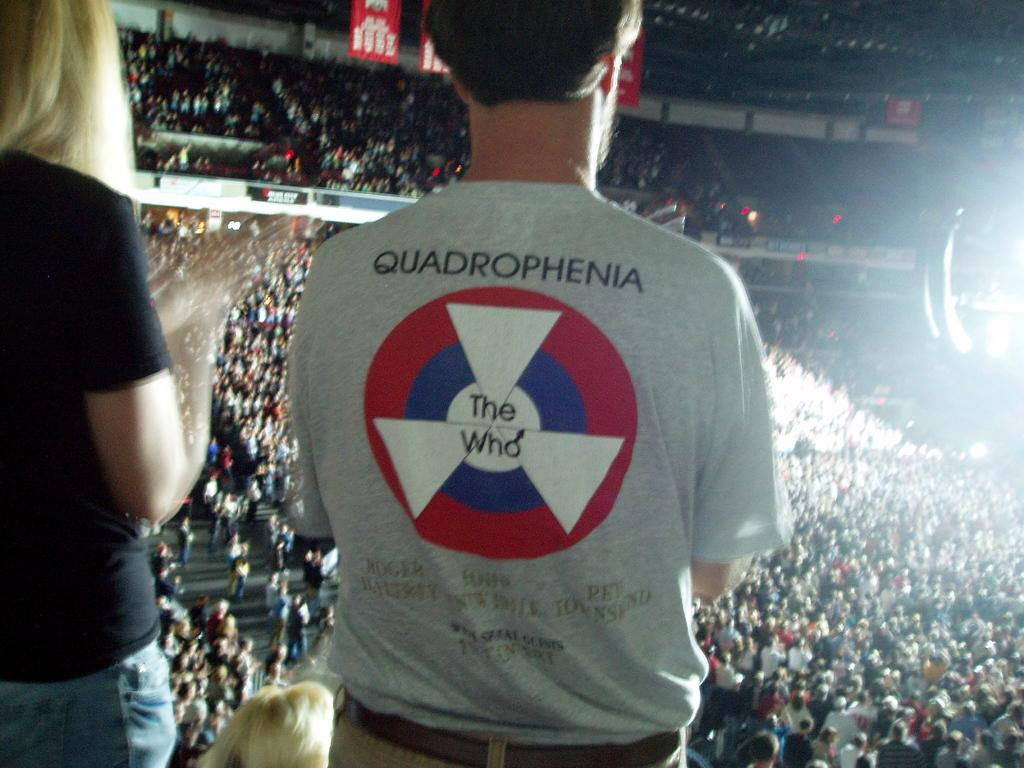<image>
Describe the image concisely. A man wearing a shirt that says Quadrophenia on the back. 